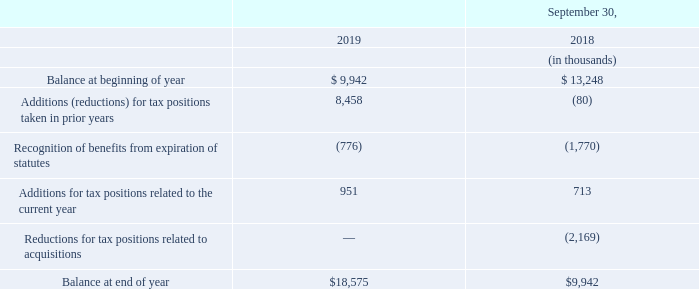Accounting for Uncertainty in Income Taxes
During fiscal 2019 and 2018, the aggregate changes in our total gross amount of unrecognized tax benefits are summarized as follows:
At September 30, 2019 and 2018, the amount of unrecognized tax benefits that, if recognized, would affect the effective tax rate was $0.7 million and $1.8 million, respectively. During fiscal year 2020, it is reasonably possible that resolution of reviews by taxing authorities, both domestic and foreign, could be reached with respect to an immaterial amount of net unrecognized tax benefits depending on the timing of examinations or expiration of statutes of limitations, either because our tax positions are sustained or because we agree to the disallowance and pay the related income tax. We recognize interest and/or penalties related to income tax matters in income tax expense. The amount of net interest and penalties recognized as a component of income tax expense during fiscal 2019 and 2018 were not material.
We are subject to ongoing audits from various taxing authorities in the jurisdictions in which we do business. As of September 30, 2019, the fiscal years open under the statute of limitations in significant jurisdictions include 2016 through 2019 in the U.S. We believe we have adequately provided for uncertain tax issues we have not yet resolved with federal, state and foreign tax authorities. Although not more likely than not, the most adverse resolution of these issues could result in additional charges to earnings in future periods. Based upon a consideration of all relevant facts and circumstances, we do not believe the ultimate resolution of uncertain tax issues for all open tax periods will have a material adverse effect upon our financial condition or results of operations.
Cash amounts paid for income taxes, net of refunds received, were $28.7 million, $15.7 million and $1.6 million in 2019, 2018 and 2017, respectively.
What is the balance at end of year for 2019?
Answer scale should be: thousand. $18,575. What is the cash amount paid for income taxes, net of refunds received in 2019? $28.7 million. In the table of aggregate changes in the total gross amount of unrecognized tax benefits, which items concern Additions? Additions (reductions) for tax positions taken in prior years, additions for tax positions related to the current year. What is the total cash amounts paid for income taxes, net of refunds received in 2017, 2018 and 2019?
Answer scale should be: million. 28.7+15.7+1.6
Answer: 46. What is the percentage change in additions for tax positions related to the current year in 2019 from 2018?
Answer scale should be: percent. (951-713)/713
Answer: 33.38. In which year was the amount of unrecognized tax benefits higher? 1.8>0.7
Answer: 2018. 